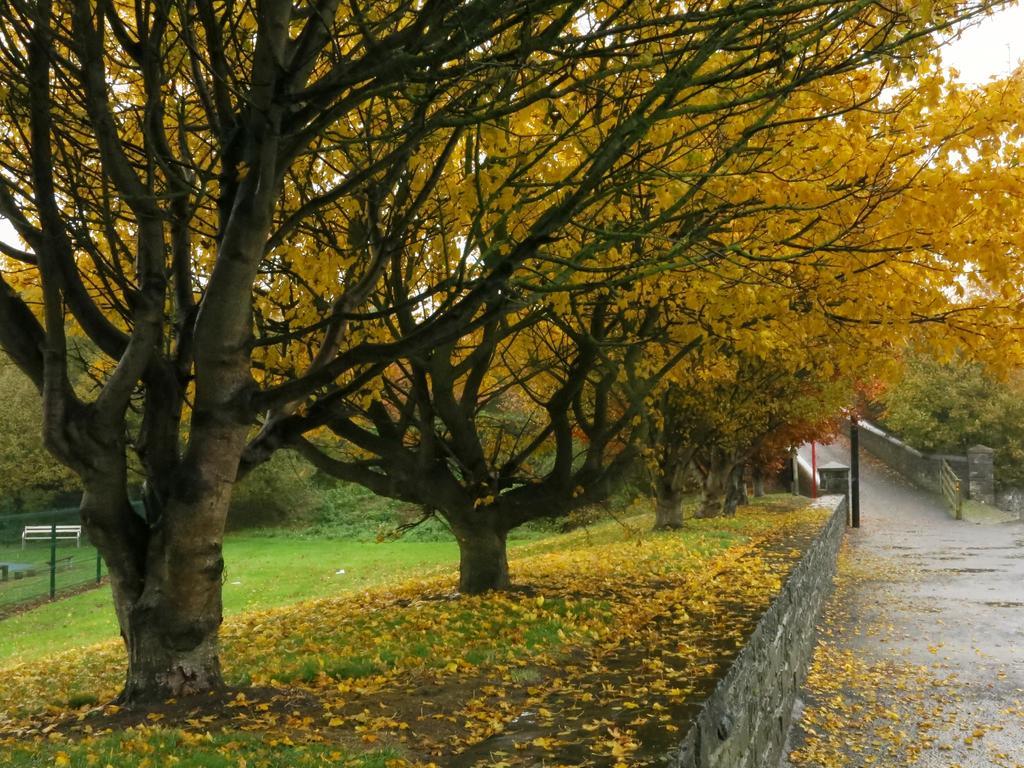How would you summarize this image in a sentence or two? In this image we can see few trees with flowers, there is a bench, grass and there is a pole and a metal object looks like a gate on the road and the sky in the background. 